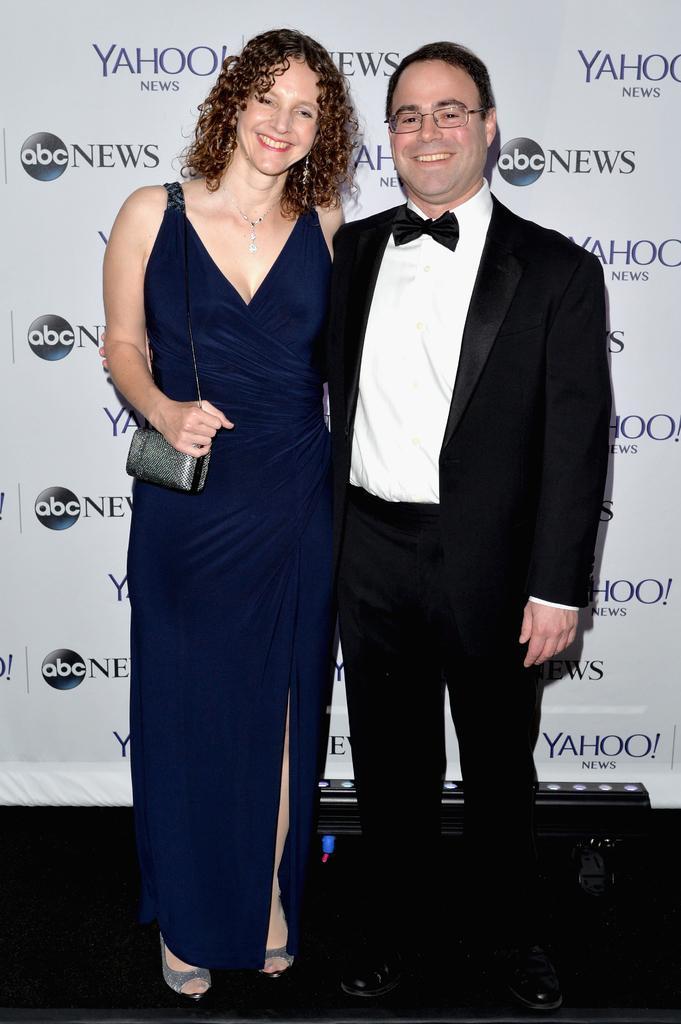Can you describe this image briefly? This image is taken indoors. In the background there is a banner with a text on it. At the bottom of the image there is a dais. In the middle of the image of man and a woman are standing on the dais and they are with smiling faces. 